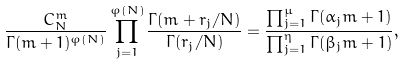Convert formula to latex. <formula><loc_0><loc_0><loc_500><loc_500>\frac { C _ { N } ^ { m } } { \Gamma ( m + 1 ) ^ { \varphi ( N ) } } \prod _ { j = 1 } ^ { \varphi ( N ) } \frac { \Gamma ( m + r _ { j } / N ) } { \Gamma ( r _ { j } / N ) } = \frac { \prod _ { j = 1 } ^ { \mu } \Gamma ( \alpha _ { j } m + 1 ) } { \prod _ { j = 1 } ^ { \eta } \Gamma ( \beta _ { j } m + 1 ) } ,</formula> 